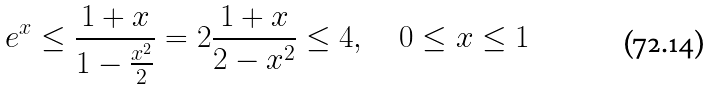<formula> <loc_0><loc_0><loc_500><loc_500>e ^ { x } \leq { \frac { 1 + x } { 1 - { \frac { x ^ { 2 } } { 2 } } } } = 2 { \frac { 1 + x } { 2 - x ^ { 2 } } } \leq 4 , \quad 0 \leq x \leq 1</formula> 